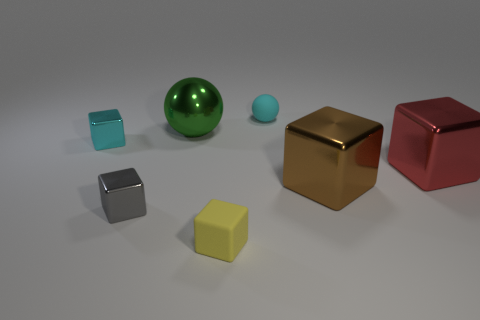Is the color of the large thing that is behind the tiny cyan metallic object the same as the rubber thing behind the big brown thing?
Keep it short and to the point. No. How many other things are there of the same shape as the gray shiny object?
Make the answer very short. 4. Are there any red rubber balls?
Keep it short and to the point. No. What number of objects are small cyan shiny cubes or metallic things on the right side of the gray block?
Make the answer very short. 4. Do the matte object that is in front of the cyan rubber ball and the small gray shiny block have the same size?
Provide a succinct answer. Yes. How many other things are there of the same size as the cyan metallic block?
Offer a terse response. 3. The tiny matte cube is what color?
Your answer should be very brief. Yellow. There is a yellow thing in front of the large red metallic block; what is its material?
Provide a short and direct response. Rubber. Are there an equal number of green shiny balls behind the green thing and green objects?
Provide a short and direct response. No. Is the shape of the cyan rubber object the same as the large brown metal object?
Offer a very short reply. No. 